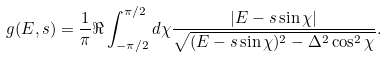Convert formula to latex. <formula><loc_0><loc_0><loc_500><loc_500>g ( E , s ) = \frac { 1 } { \pi } \Re \int _ { - \pi / 2 } ^ { \pi / 2 } d \chi \frac { | E - s \sin \chi | } { \sqrt { ( E - s \sin \chi ) ^ { 2 } - \Delta ^ { 2 } \cos ^ { 2 } \chi } } .</formula> 